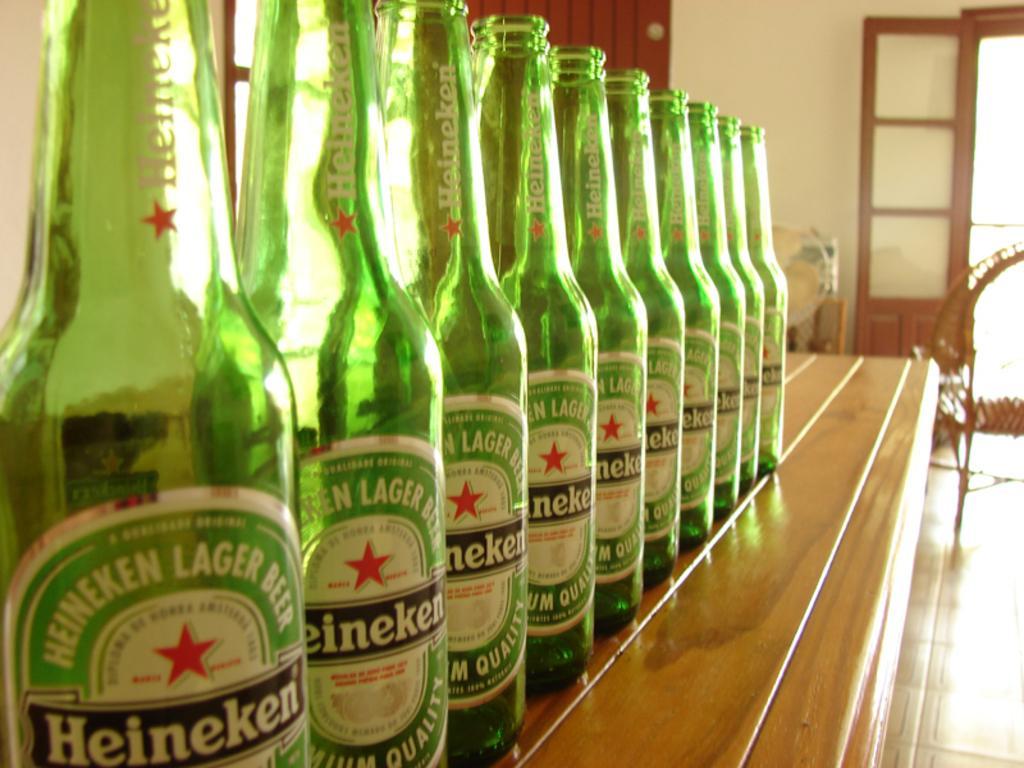How would you summarize this image in a sentence or two? There are few wine bottles on the table. On the right there is a door. 